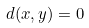<formula> <loc_0><loc_0><loc_500><loc_500>d ( x , y ) = 0</formula> 